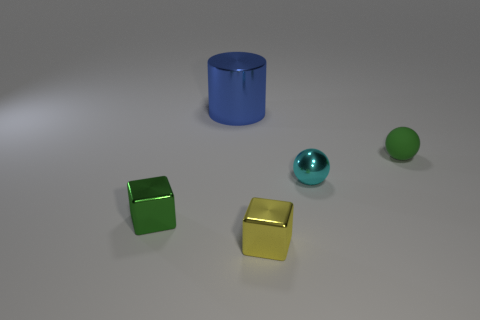Add 3 cyan shiny balls. How many objects exist? 8 Subtract all blocks. How many objects are left? 3 Subtract 0 gray blocks. How many objects are left? 5 Subtract all large gray things. Subtract all blue metal cylinders. How many objects are left? 4 Add 5 small cyan spheres. How many small cyan spheres are left? 6 Add 5 large cyan matte blocks. How many large cyan matte blocks exist? 5 